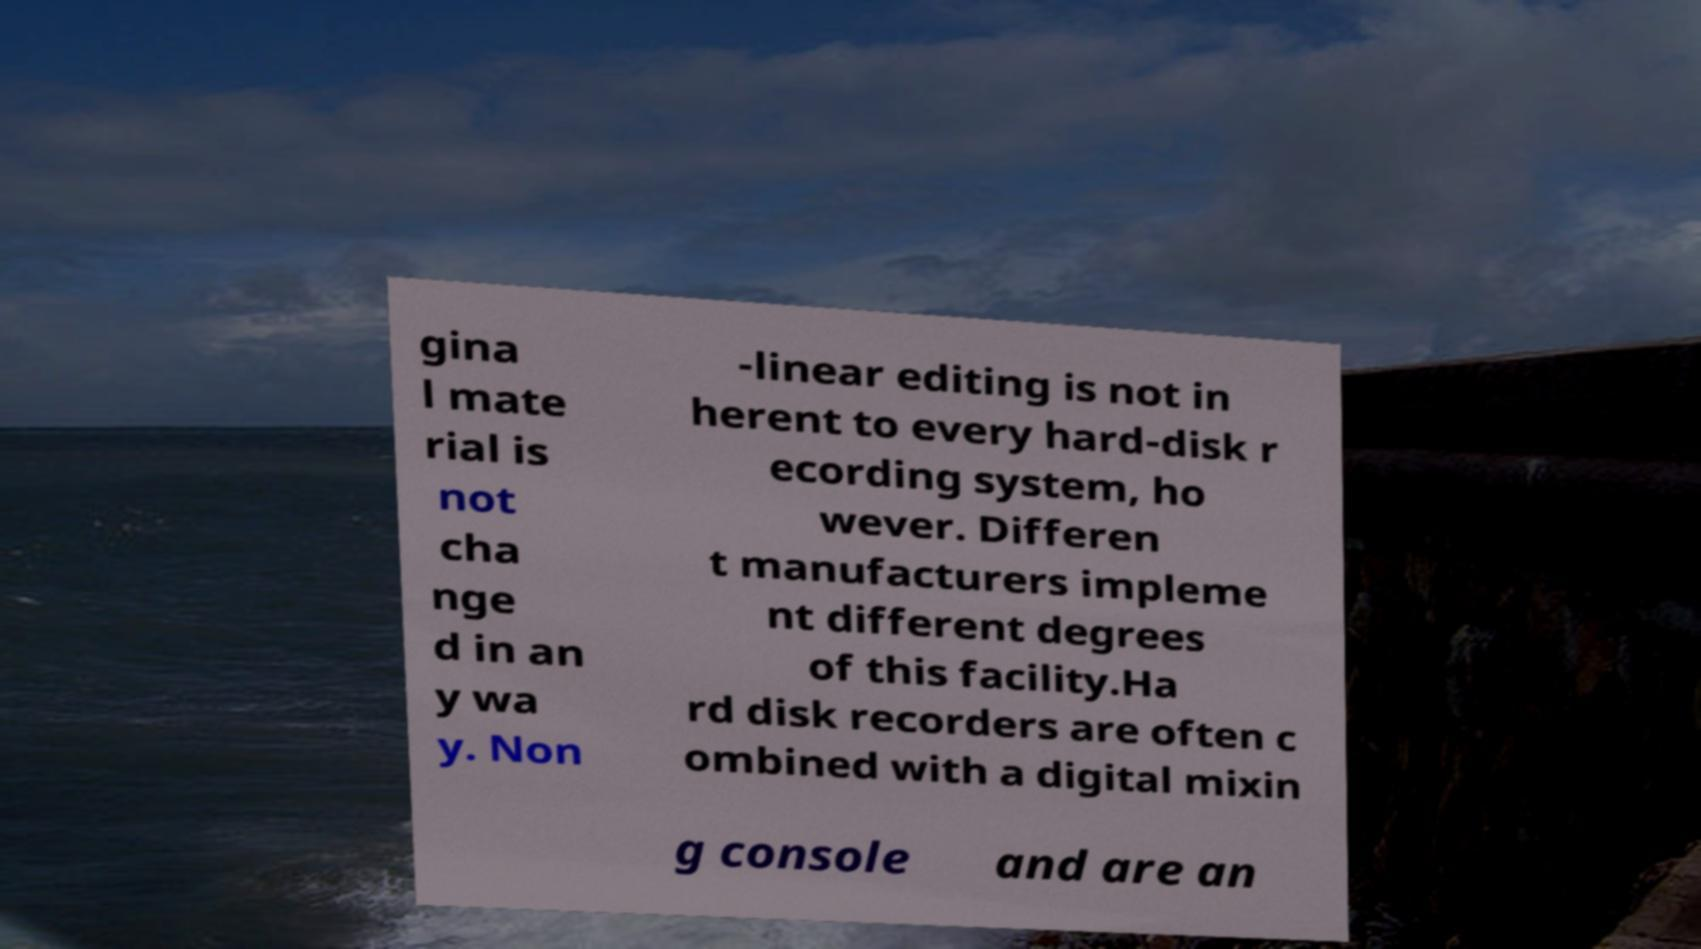Could you extract and type out the text from this image? gina l mate rial is not cha nge d in an y wa y. Non -linear editing is not in herent to every hard-disk r ecording system, ho wever. Differen t manufacturers impleme nt different degrees of this facility.Ha rd disk recorders are often c ombined with a digital mixin g console and are an 